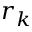Convert formula to latex. <formula><loc_0><loc_0><loc_500><loc_500>r _ { k }</formula> 